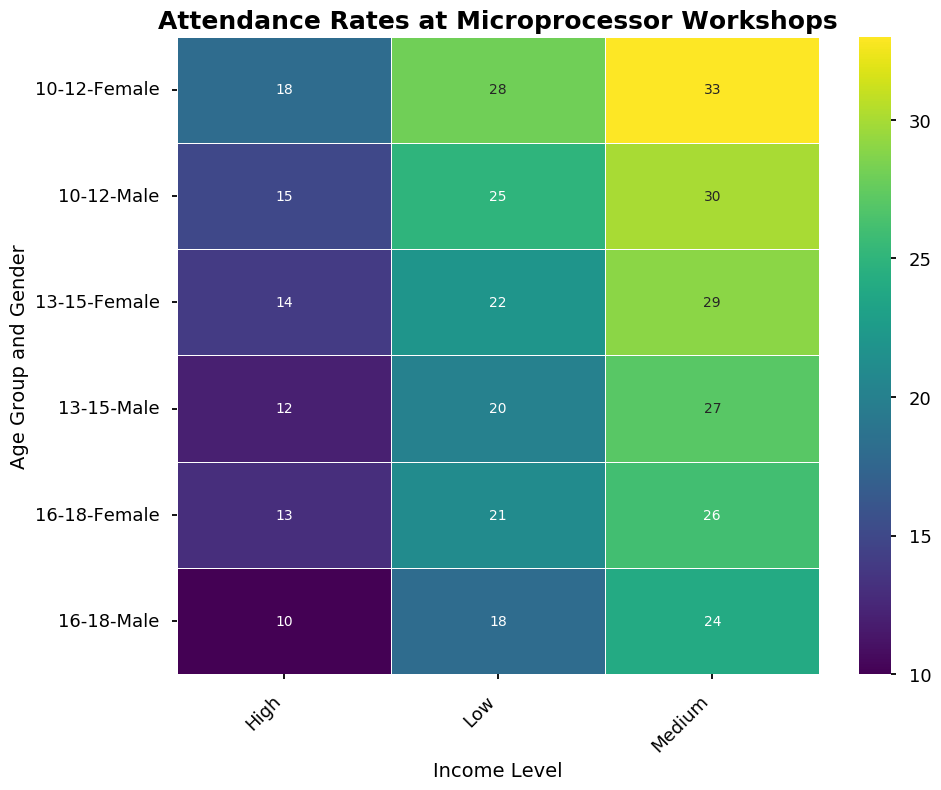What is the attendance rate for 10-12 year old females with medium income? Look for the intersection of '10-12' in the Age_Group row, 'Female' in the Gender row, and 'Medium' in the Income_Level column. The value there is 33.
Answer: 33 Between males and females aged 13-15 from low-income backgrounds, who has a higher attendance rate? Compare the attendance rates for 13-15 year old males (20) and females (22) from low-income backgrounds. The value for females is higher.
Answer: Females What is the difference in attendance rates between 16-18 year old males with high income and medium income? Look at the attendance rates for 16-18 year old males from high-income (10) and medium-income (24) backgrounds and subtract the higher income rate from the medium one. 24 - 10 equals 14.
Answer: 14 Which income level has the lowest attendance rate for 13-15 year old females? Compare the attendance rates for 13-15 year old females with low-income (22), medium-income (29), and high-income (14). The lowest rate is 14 for high-income.
Answer: High What is the average attendance rate for 10-12 year old males across all income levels? Sum the attendance rates for 10-12 year old males from low (25), medium (30), and high (15) income levels, then divide by 3. (25 + 30 + 15) / 3 = 70 / 3 = 23.33
Answer: 23.33 Which group has the highest attendance rate overall? By looking at the entire heatmap, the highest value in attendance rates is 33 for 10-12 year old females with medium income.
Answer: 10-12 Female Medium Are attendance rates generally higher for 16-18 year old females or males across all income levels? Compare the sum of the attendance rates for 16-18 year old males (18 + 24 + 10) and females (21 + 26 + 13). Females sum up to 60, and males sum up to 52. Females have a higher total attendance rate.
Answer: Females What is the combined attendance rate for 13-15 year old females with low and high incomes? Add the attendance rates for 13-15 year old females from low-income (22) and high-income (14) levels. 22 + 14 = 36
Answer: 36 Which age and gender group has the most consistent attendance across different income levels? Assess the variance or range in attendance rates for each age and gender group across income levels. The group with the smallest difference between their highest and lowest attendance rates is chosen. The 16-18 year old females vary from 21 to 26 to 13, with a range of 13, which is consistent compared to other groups.
Answer: 16-18 Female How does the attendance of 10-12 year old females with low income compare to 16-18 year old females with low income? Compare the attendance rates of 10-12 year old females with low income (28) to 16-18 year old females with low income (21). 28 is higher than 21.
Answer: 10-12 year old females with low income have higher attendance 